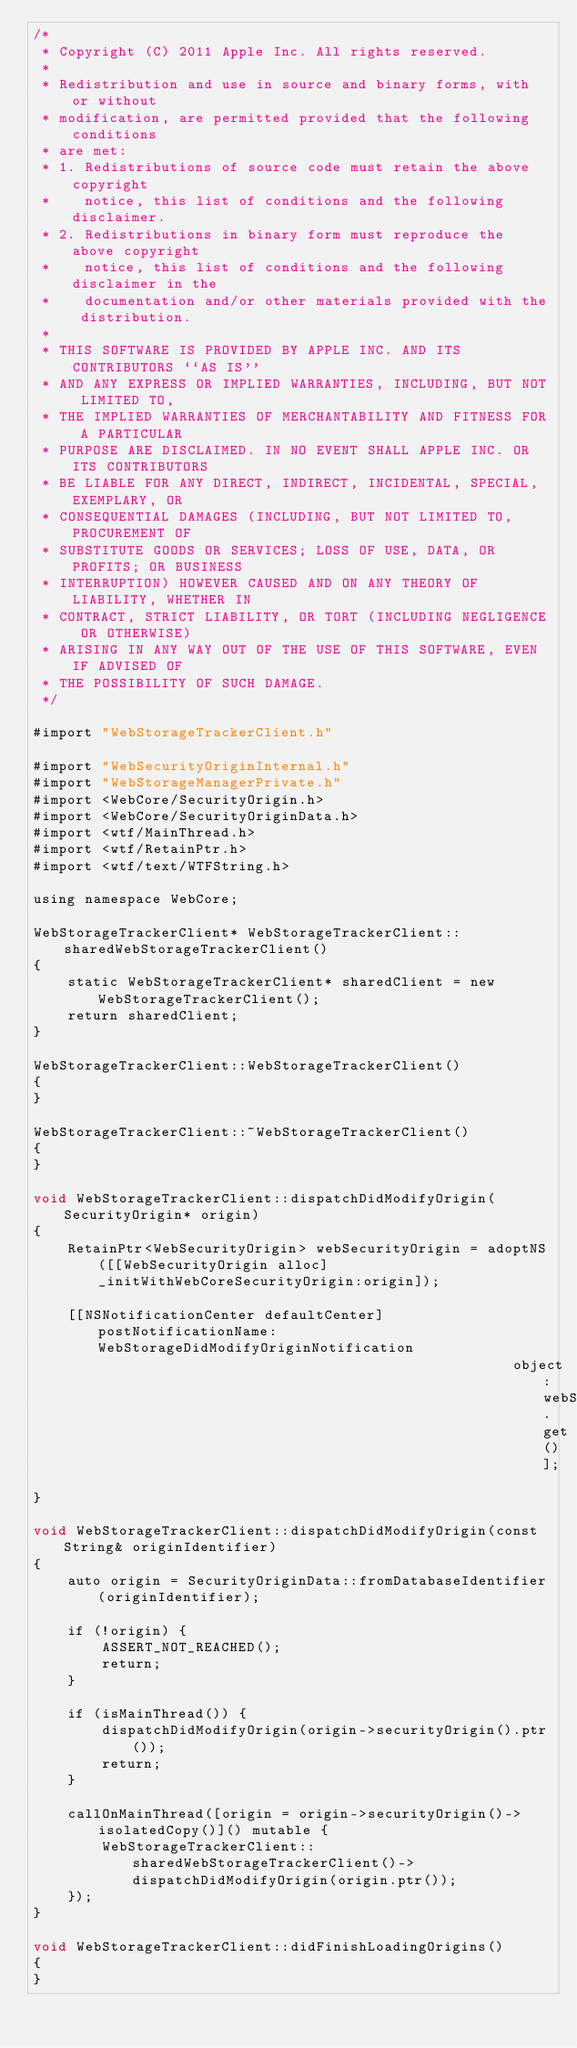<code> <loc_0><loc_0><loc_500><loc_500><_ObjectiveC_>/*
 * Copyright (C) 2011 Apple Inc. All rights reserved.
 *
 * Redistribution and use in source and binary forms, with or without
 * modification, are permitted provided that the following conditions
 * are met:
 * 1. Redistributions of source code must retain the above copyright
 *    notice, this list of conditions and the following disclaimer.
 * 2. Redistributions in binary form must reproduce the above copyright
 *    notice, this list of conditions and the following disclaimer in the
 *    documentation and/or other materials provided with the distribution.
 *
 * THIS SOFTWARE IS PROVIDED BY APPLE INC. AND ITS CONTRIBUTORS ``AS IS''
 * AND ANY EXPRESS OR IMPLIED WARRANTIES, INCLUDING, BUT NOT LIMITED TO,
 * THE IMPLIED WARRANTIES OF MERCHANTABILITY AND FITNESS FOR A PARTICULAR
 * PURPOSE ARE DISCLAIMED. IN NO EVENT SHALL APPLE INC. OR ITS CONTRIBUTORS
 * BE LIABLE FOR ANY DIRECT, INDIRECT, INCIDENTAL, SPECIAL, EXEMPLARY, OR
 * CONSEQUENTIAL DAMAGES (INCLUDING, BUT NOT LIMITED TO, PROCUREMENT OF
 * SUBSTITUTE GOODS OR SERVICES; LOSS OF USE, DATA, OR PROFITS; OR BUSINESS
 * INTERRUPTION) HOWEVER CAUSED AND ON ANY THEORY OF LIABILITY, WHETHER IN
 * CONTRACT, STRICT LIABILITY, OR TORT (INCLUDING NEGLIGENCE OR OTHERWISE)
 * ARISING IN ANY WAY OUT OF THE USE OF THIS SOFTWARE, EVEN IF ADVISED OF
 * THE POSSIBILITY OF SUCH DAMAGE.
 */

#import "WebStorageTrackerClient.h"

#import "WebSecurityOriginInternal.h"
#import "WebStorageManagerPrivate.h"
#import <WebCore/SecurityOrigin.h>
#import <WebCore/SecurityOriginData.h>
#import <wtf/MainThread.h>
#import <wtf/RetainPtr.h>
#import <wtf/text/WTFString.h>

using namespace WebCore;

WebStorageTrackerClient* WebStorageTrackerClient::sharedWebStorageTrackerClient()
{
    static WebStorageTrackerClient* sharedClient = new WebStorageTrackerClient();
    return sharedClient;
}

WebStorageTrackerClient::WebStorageTrackerClient()
{
}

WebStorageTrackerClient::~WebStorageTrackerClient()
{
}

void WebStorageTrackerClient::dispatchDidModifyOrigin(SecurityOrigin* origin)
{
    RetainPtr<WebSecurityOrigin> webSecurityOrigin = adoptNS([[WebSecurityOrigin alloc] _initWithWebCoreSecurityOrigin:origin]);

    [[NSNotificationCenter defaultCenter] postNotificationName:WebStorageDidModifyOriginNotification 
                                                        object:webSecurityOrigin.get()];
}

void WebStorageTrackerClient::dispatchDidModifyOrigin(const String& originIdentifier)
{
    auto origin = SecurityOriginData::fromDatabaseIdentifier(originIdentifier);

    if (!origin) {
        ASSERT_NOT_REACHED();
        return;
    }
    
    if (isMainThread()) {
        dispatchDidModifyOrigin(origin->securityOrigin().ptr());
        return;
    }

    callOnMainThread([origin = origin->securityOrigin()->isolatedCopy()]() mutable {
        WebStorageTrackerClient::sharedWebStorageTrackerClient()->dispatchDidModifyOrigin(origin.ptr());
    });
}

void WebStorageTrackerClient::didFinishLoadingOrigins()
{
}
</code> 